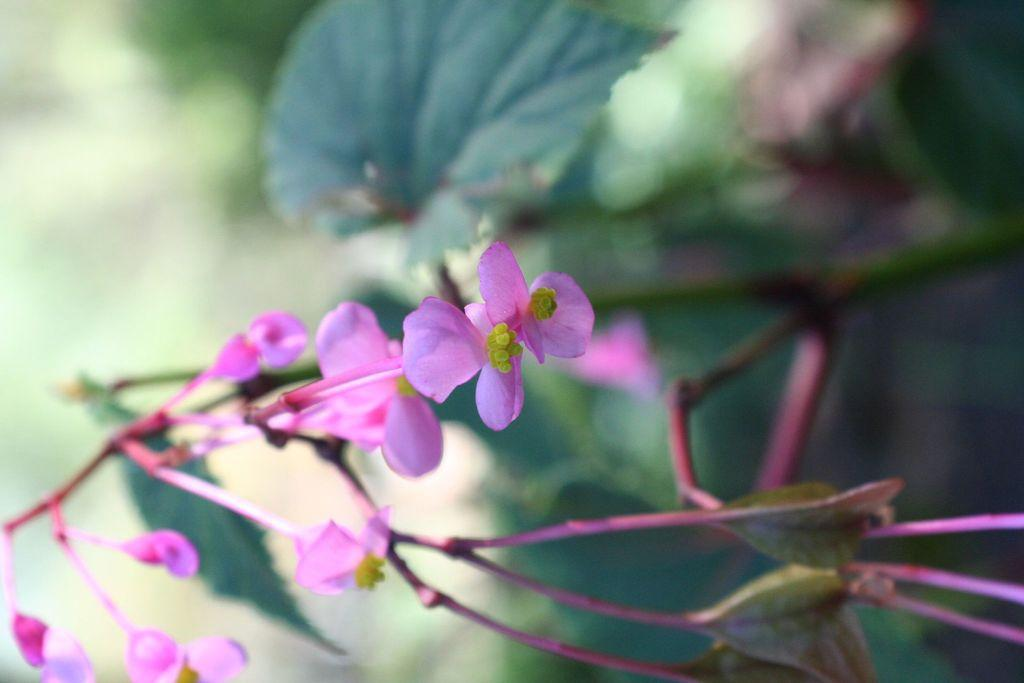What type of plants can be seen in the image? There are flowers in the image. What else can be seen in the background of the image? There are leaves in the background of the image. How would you describe the clarity of the image? The image is blurry. How much payment is required to obtain the hook shown in the image? There is no hook present in the image, so it is not possible to determine any payment required. 